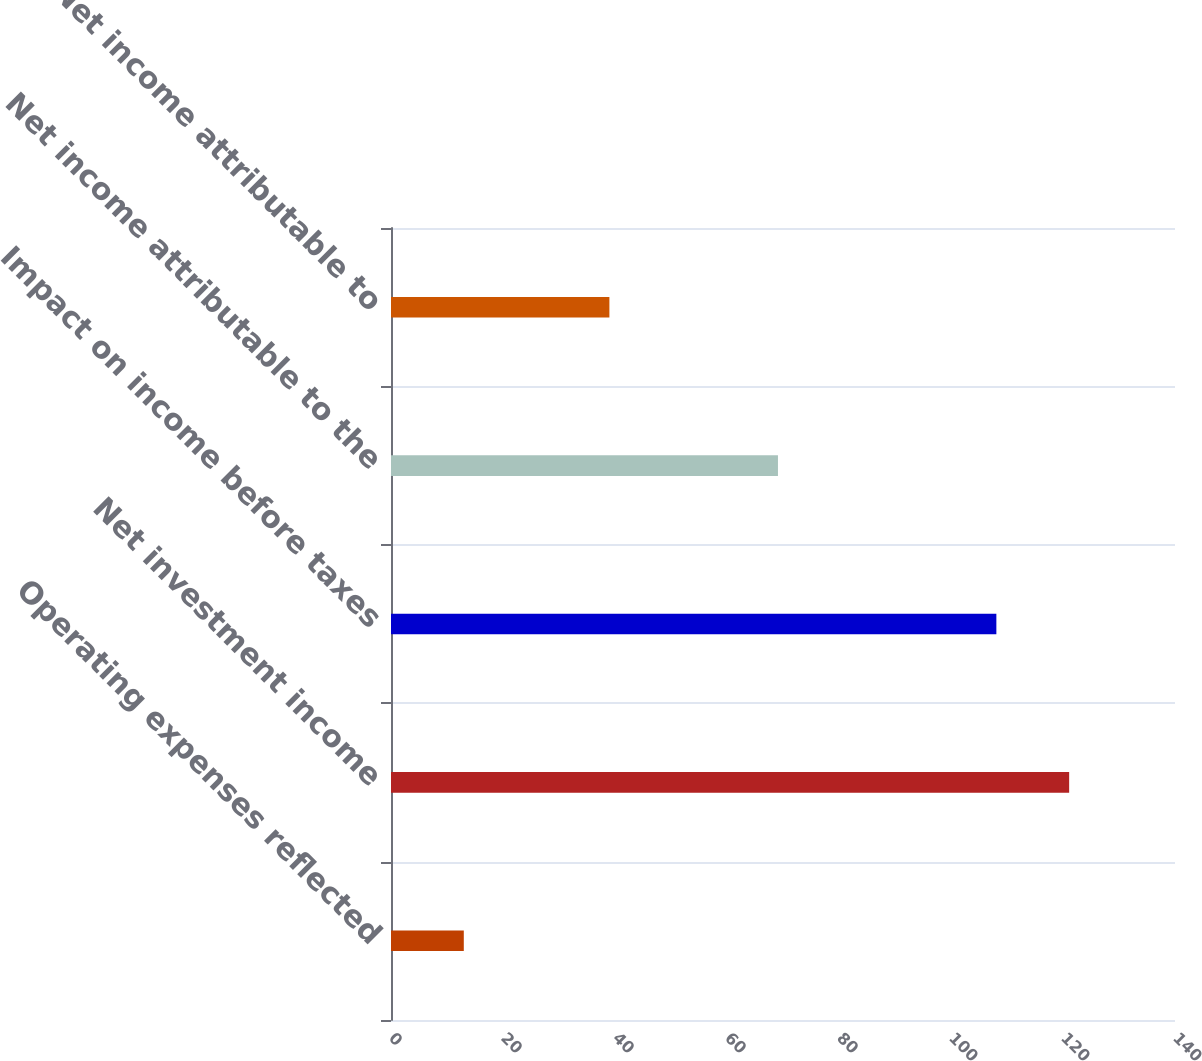Convert chart to OTSL. <chart><loc_0><loc_0><loc_500><loc_500><bar_chart><fcel>Operating expenses reflected<fcel>Net investment income<fcel>Impact on income before taxes<fcel>Net income attributable to the<fcel>Net income attributable to<nl><fcel>13<fcel>121.1<fcel>108.1<fcel>69.1<fcel>39<nl></chart> 